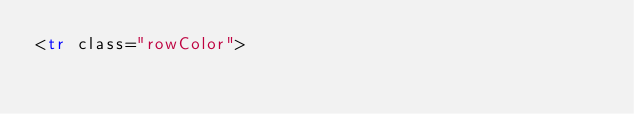<code> <loc_0><loc_0><loc_500><loc_500><_HTML_><tr class="rowColor"></code> 